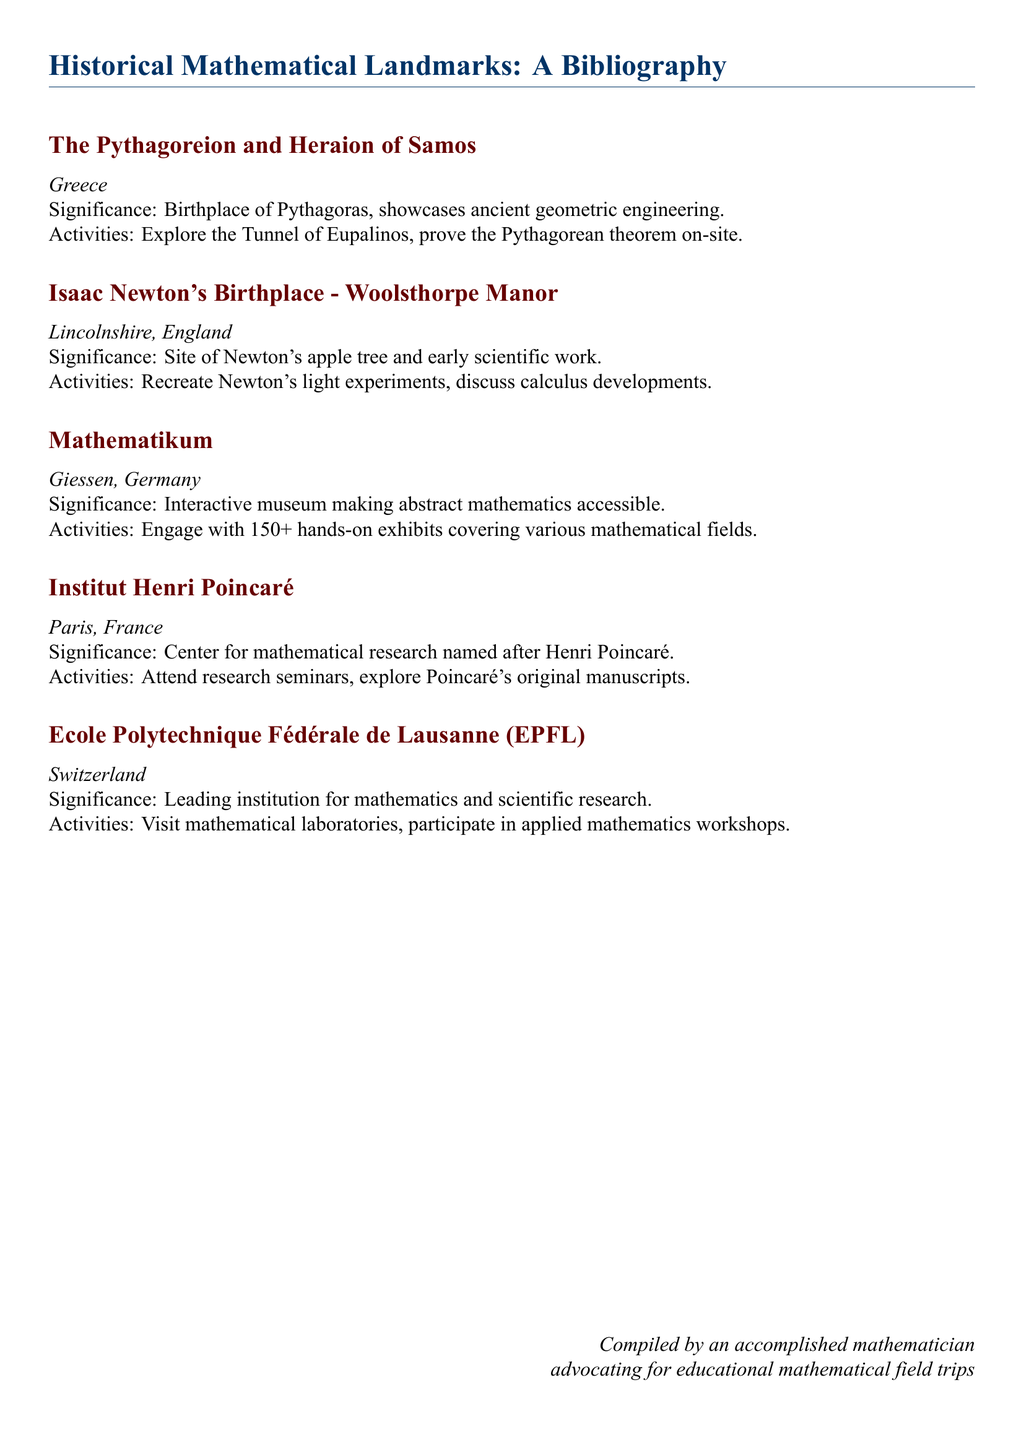What is the birthplace of Pythagoras? The document mentions the Pythagoreion and Heraion of Samos as the birthplace of Pythagoras.
Answer: Pythagoreion and Heraion of Samos What is the historical significance of Woolsthorpe Manor? Woolsthorpe Manor is noted as the site of Newton's apple tree and early scientific work.
Answer: Site of Newton's apple tree How many hands-on exhibits are available at Mathematikum? The document states there are over 150 hands-on exhibits at Mathematikum.
Answer: 150+ Which city houses the Institut Henri Poincaré? The document lists Paris as the location of the Institut Henri Poincaré.
Answer: Paris What type of activities can one engage in at EPFL? The document suggests visiting mathematical laboratories and participating in applied mathematics workshops.
Answer: Visit laboratories, participate in workshops What is the main focus of Mathematikum? The document describes Mathematikum as an interactive museum making abstract mathematics accessible.
Answer: Making abstract mathematics accessible Which mathematician's manuscripts can be explored at the Institut Henri Poincaré? The document mentions Poincaré's original manuscripts can be explored at the Institut Henri Poincaré.
Answer: Poincaré In what country is the Ecole Polytechnique Fédérale de Lausanne located? The document states that EPFL is located in Switzerland.
Answer: Switzerland 